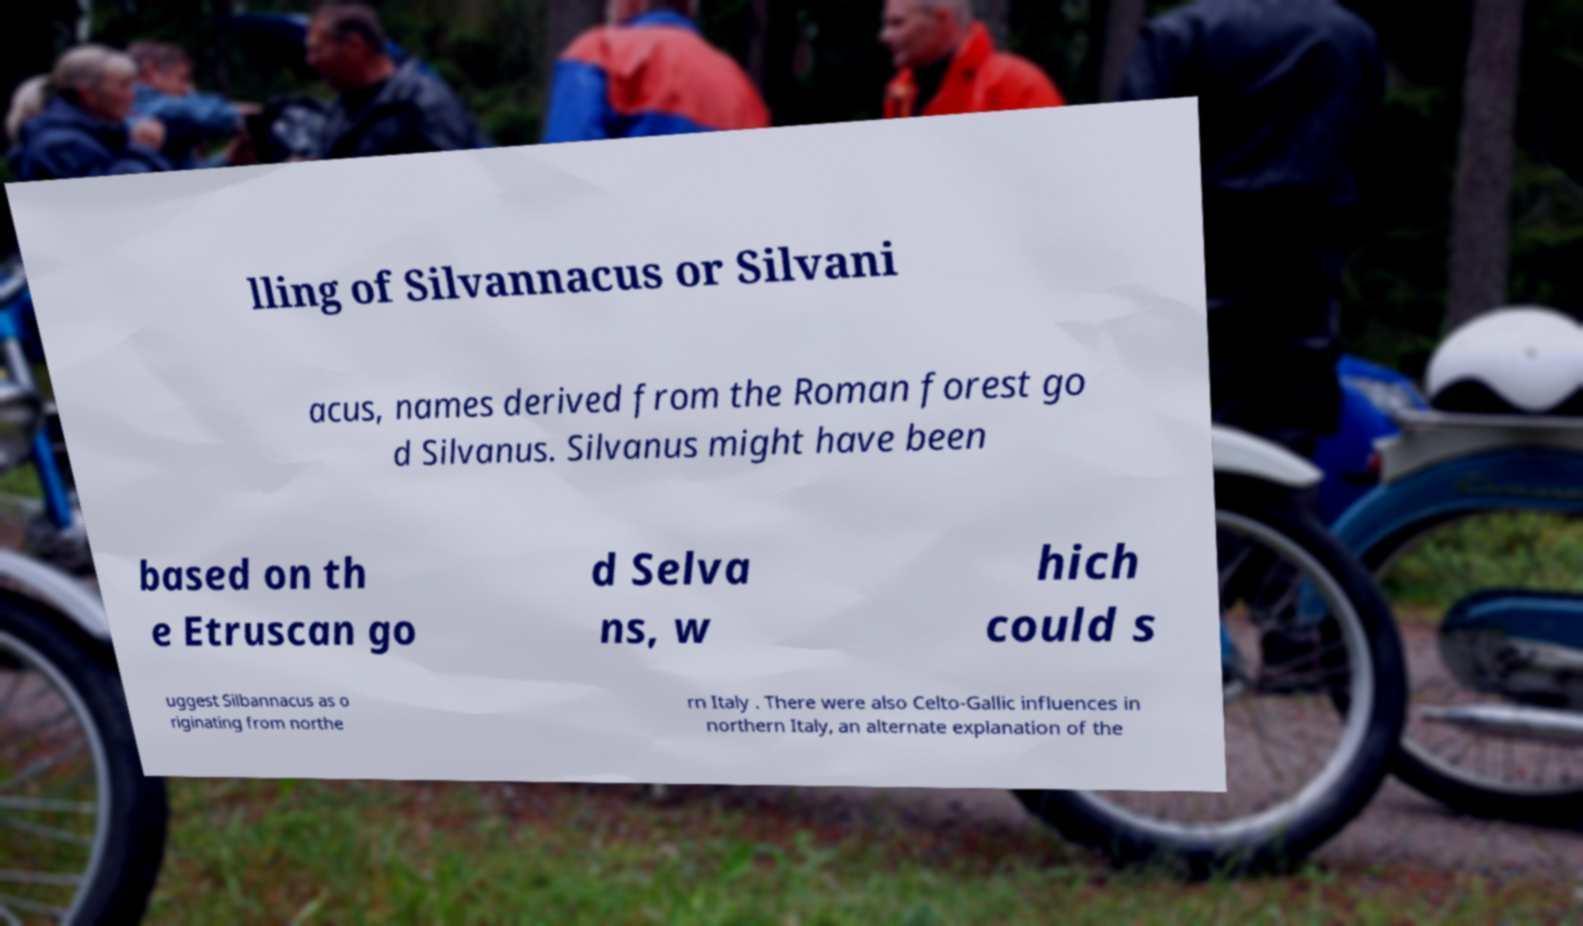What messages or text are displayed in this image? I need them in a readable, typed format. lling of Silvannacus or Silvani acus, names derived from the Roman forest go d Silvanus. Silvanus might have been based on th e Etruscan go d Selva ns, w hich could s uggest Silbannacus as o riginating from northe rn Italy . There were also Celto-Gallic influences in northern Italy, an alternate explanation of the 